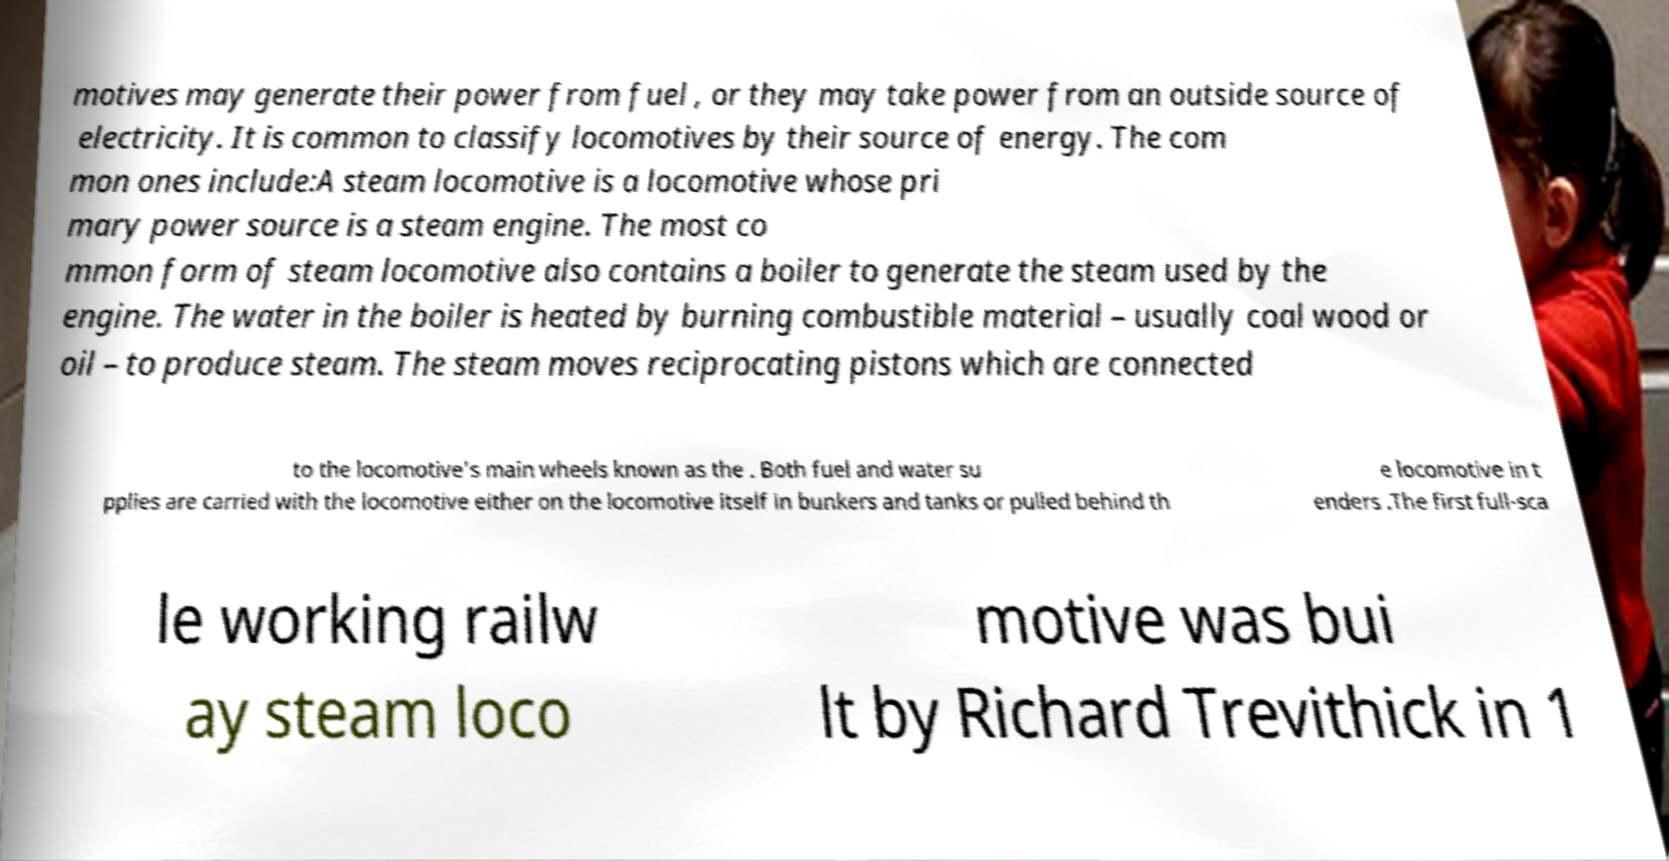There's text embedded in this image that I need extracted. Can you transcribe it verbatim? motives may generate their power from fuel , or they may take power from an outside source of electricity. It is common to classify locomotives by their source of energy. The com mon ones include:A steam locomotive is a locomotive whose pri mary power source is a steam engine. The most co mmon form of steam locomotive also contains a boiler to generate the steam used by the engine. The water in the boiler is heated by burning combustible material – usually coal wood or oil – to produce steam. The steam moves reciprocating pistons which are connected to the locomotive's main wheels known as the . Both fuel and water su pplies are carried with the locomotive either on the locomotive itself in bunkers and tanks or pulled behind th e locomotive in t enders .The first full-sca le working railw ay steam loco motive was bui lt by Richard Trevithick in 1 